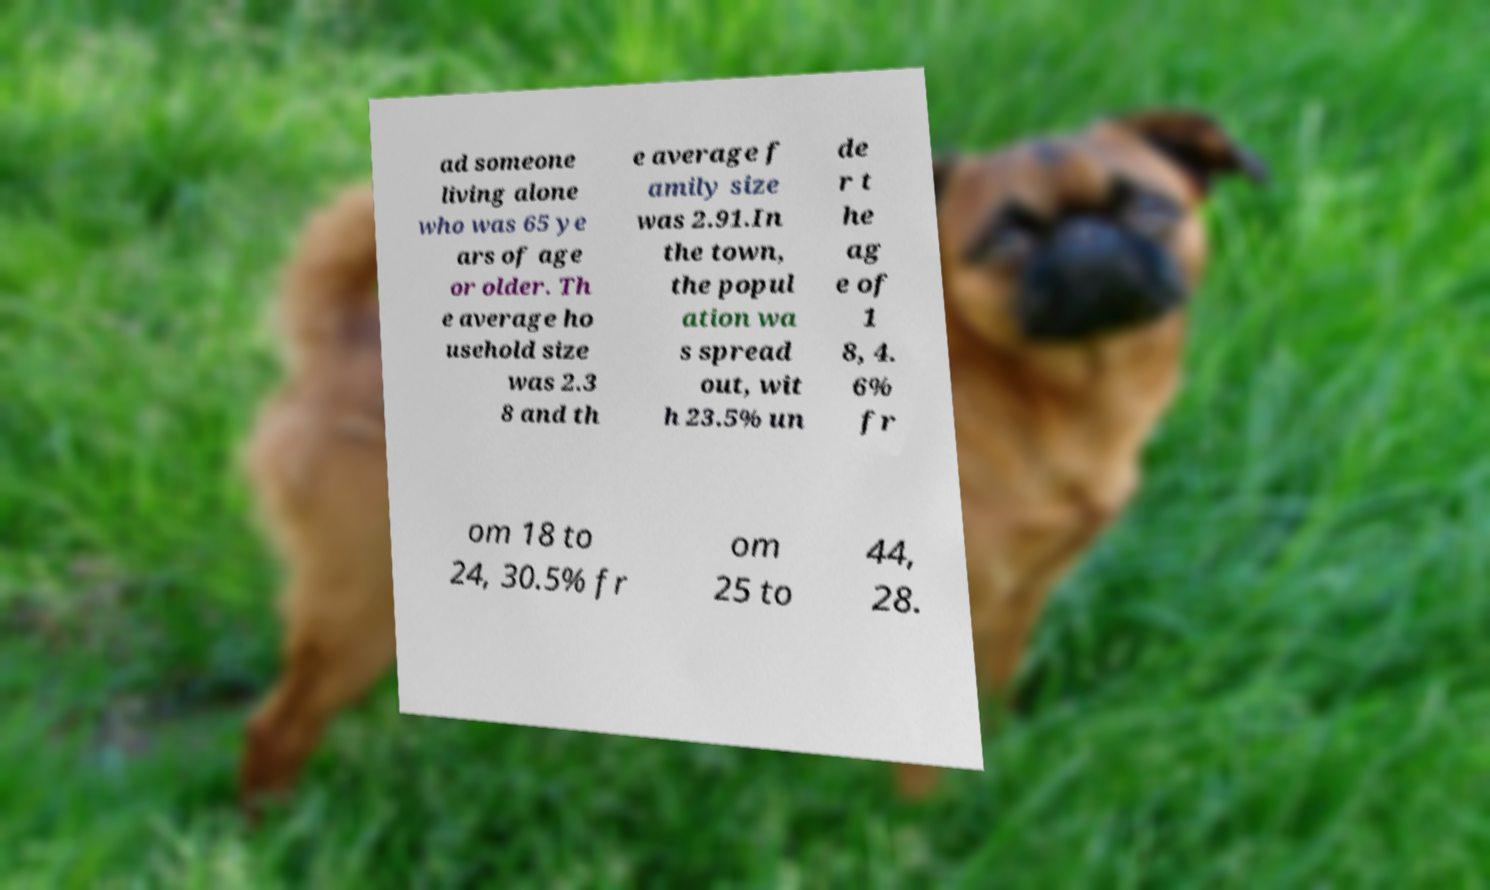Please read and relay the text visible in this image. What does it say? ad someone living alone who was 65 ye ars of age or older. Th e average ho usehold size was 2.3 8 and th e average f amily size was 2.91.In the town, the popul ation wa s spread out, wit h 23.5% un de r t he ag e of 1 8, 4. 6% fr om 18 to 24, 30.5% fr om 25 to 44, 28. 